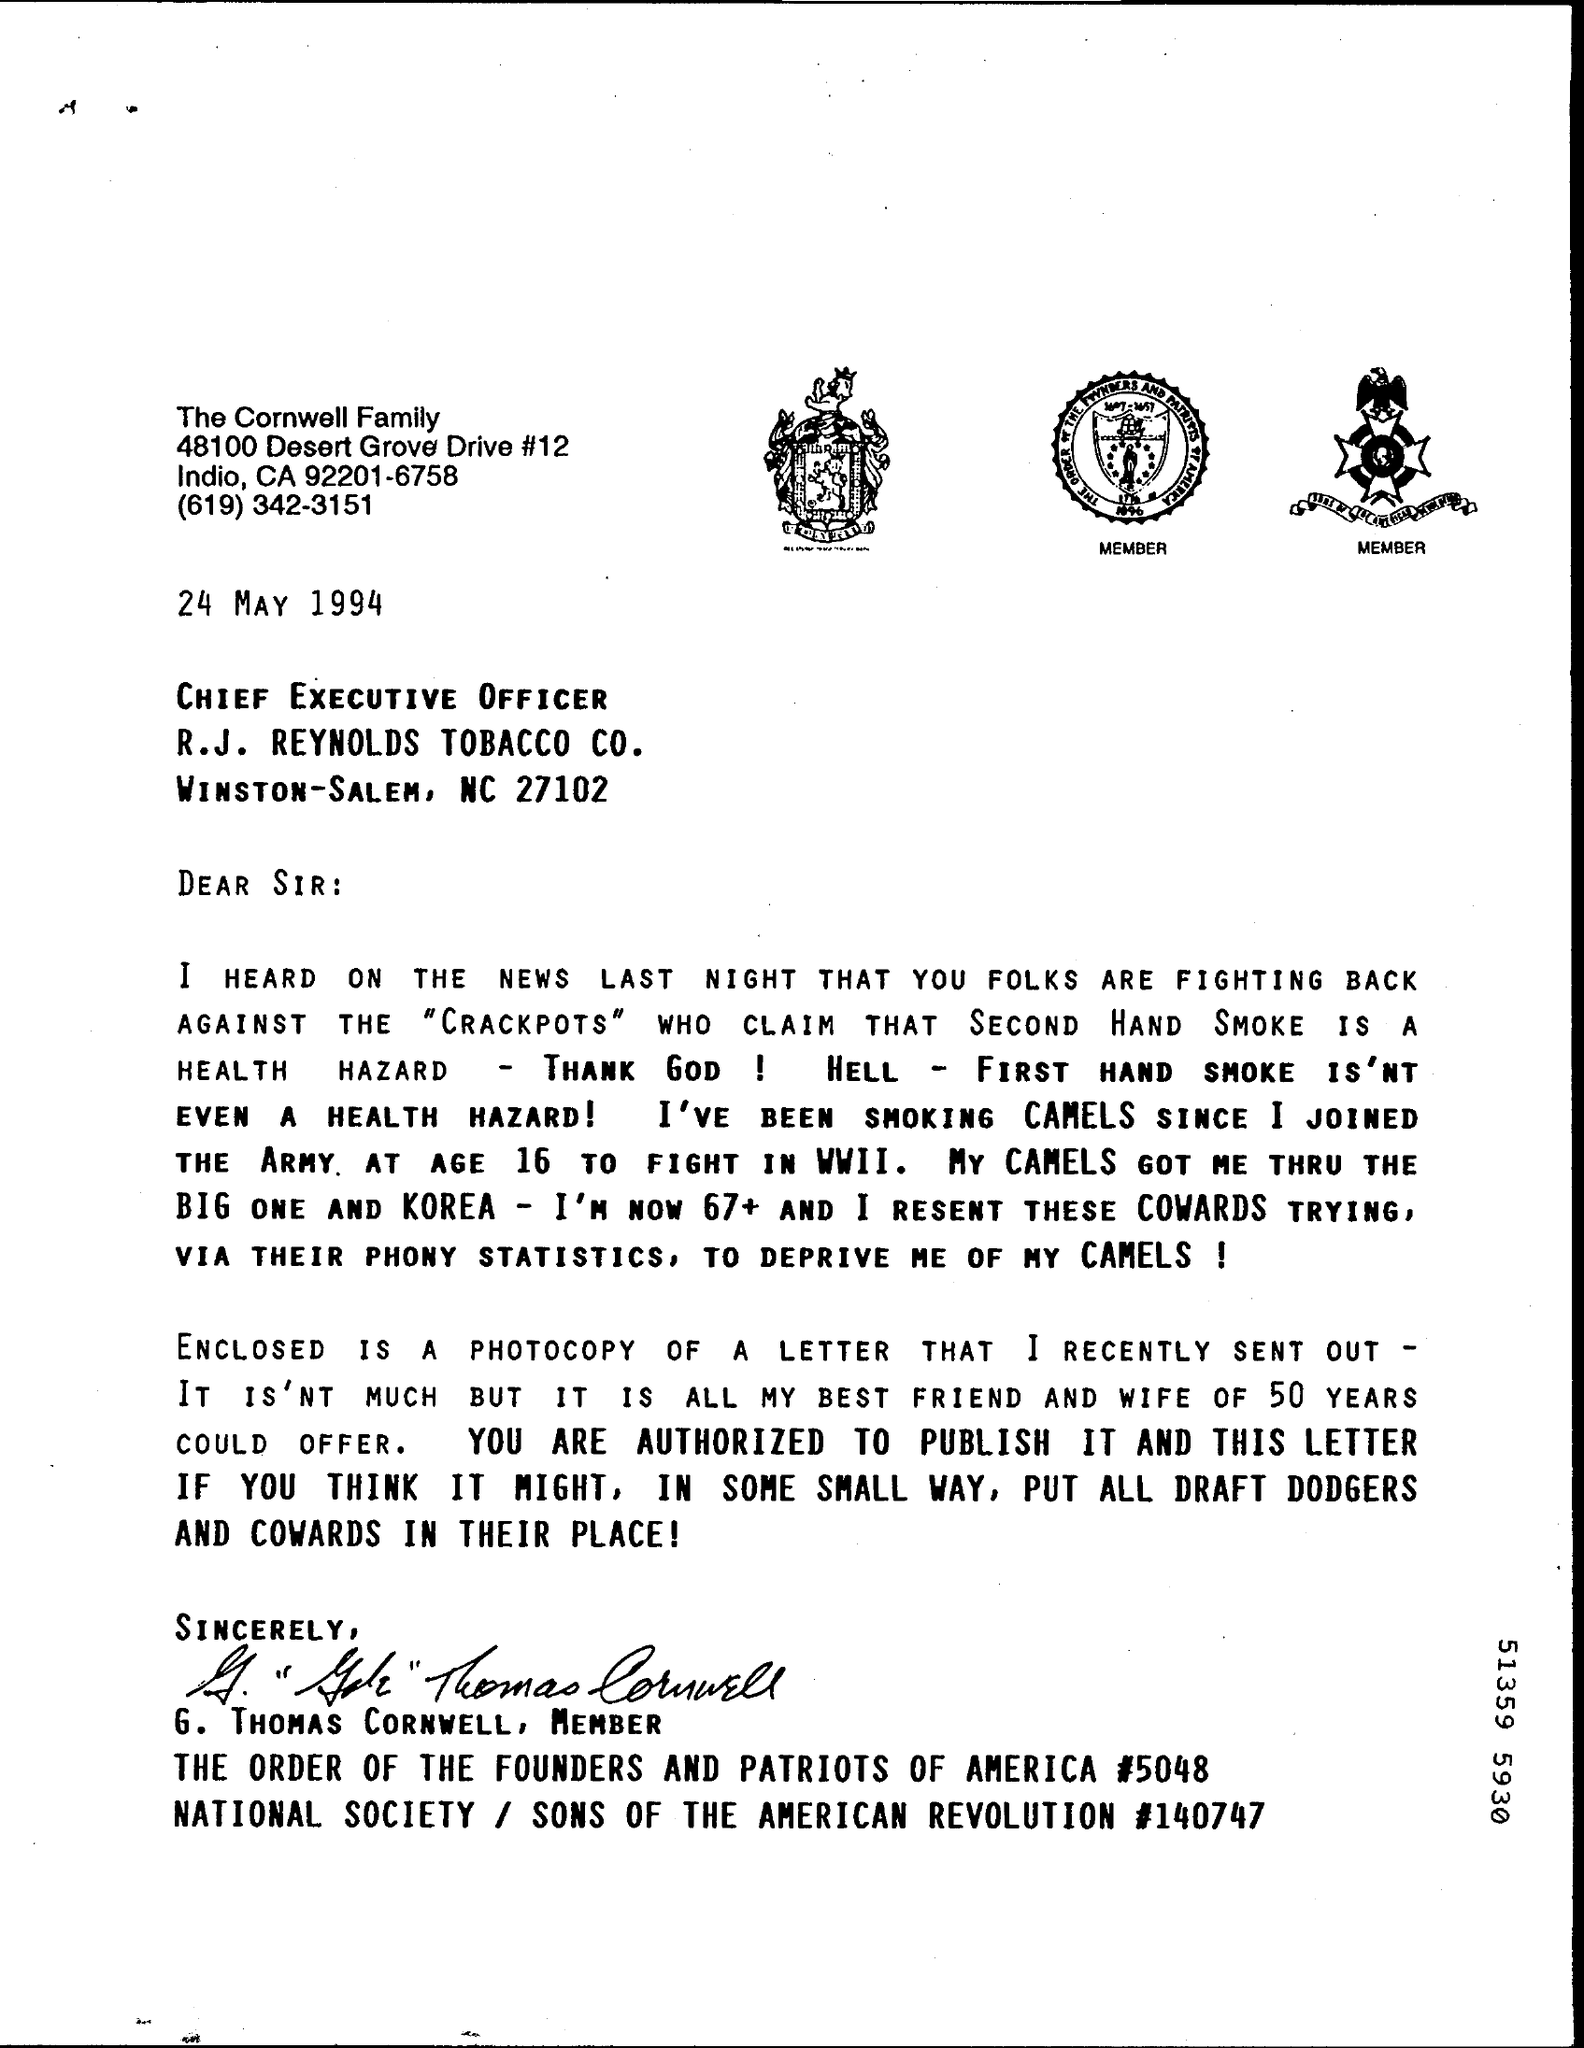When is the letter dated on?
Provide a succinct answer. 24 MAY 1994. Who is this letter from?
Keep it short and to the point. The Cornwell Family. 